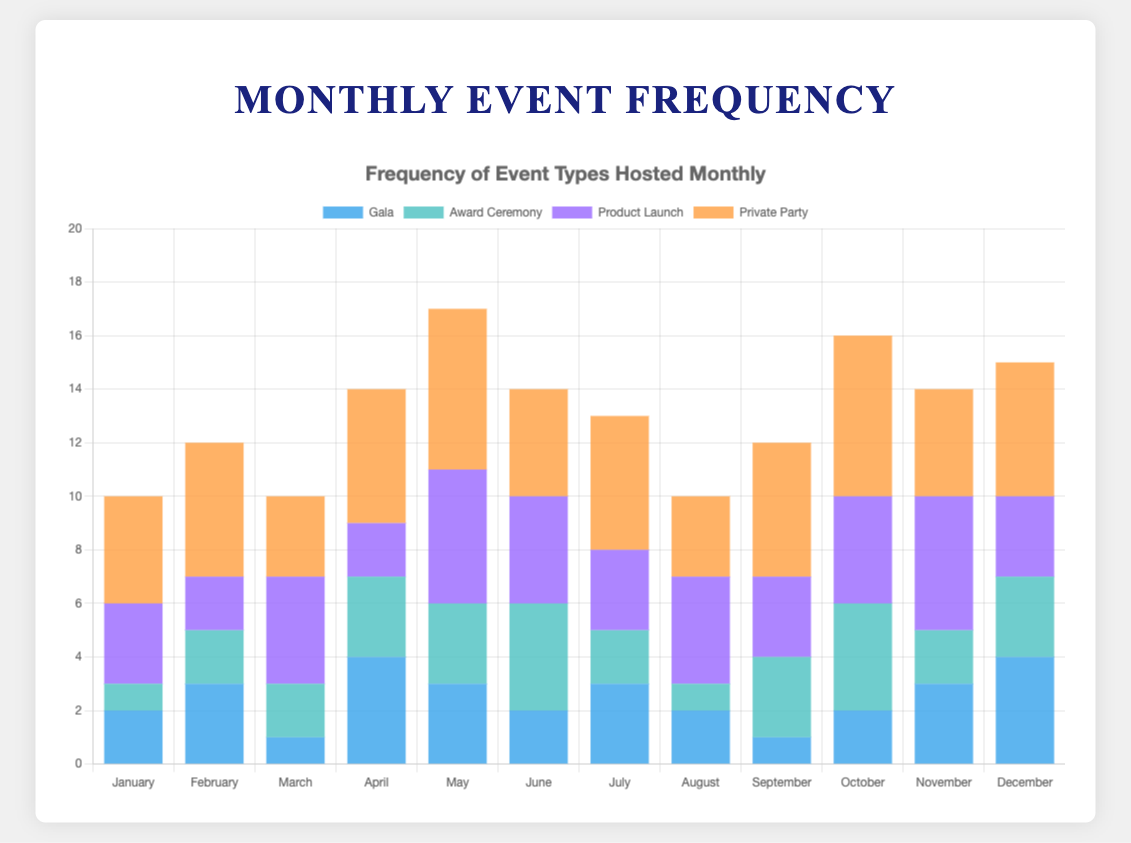Which month has the highest frequency of Private Parties? Observing the height of the bars labeled "Private Party" for each month, May and October have the tallest bars with a height of 6.
Answer: May and October What is the total number of Galas hosted in the first half of the year? Summing the values of "Gala" for January (2), February (3), March (1), April (4), May (3), and June (2): 2 + 3 + 1 + 4 + 3 + 2 = 15.
Answer: 15 How does the frequency of Award Ceremonies in June compare to January? The bar for "Award Ceremony" in June is taller than in January. June has 4 award ceremonies, while January has 1.
Answer: June has more In which month are the frequencies of "Product Launch" and "Award Ceremony" equal? By observing the heights of the bars, Product Launch and Award Ceremony both have a frequency of 3 in December.
Answer: December Considering only the months with exactly 4 Private Parties, in which month were the fewest Galas hosted? Observing the bar heights, June and November both have 4 Private Parties. Among these, June has 2 Galas and November has 3 Galas, so June has fewer.
Answer: June What is the average frequency of Award Ceremonies across all months? Summing the values of "Award Ceremony" across all months: 1 + 2 + 2 + 3 + 3 + 4 + 2 + 1 + 3 + 4 + 2 + 3 = 30. Dividing by 12 months gives 30/12 = 2.5.
Answer: 2.5 Which event type had the most consistent frequency over the months? By observing the bar heights, "Gala" shows less variation with frequencies generally around 2-4 per month.
Answer: Gala What is the difference in the frequency of Product Launches between May and August? May has 5 Product Launches and August has 4 Product Launches. The difference is 5 - 4 = 1.
Answer: 1 Did the number of Award Ceremonies ever exceed the number of Product Launches in any month? Observing the bars for Award Ceremony and Product Launch, only in June the number of Award Ceremonies (4) exceeds Product Launches (4).
Answer: Yes, in June What is the highest combined frequency of any event type in a single month? Adding the values for each event type for each month, May has the highest combined frequency: Gala (3) + Award Ceremony (3) + Product Launch (5) + Private Party (6) = 17.
Answer: 17 